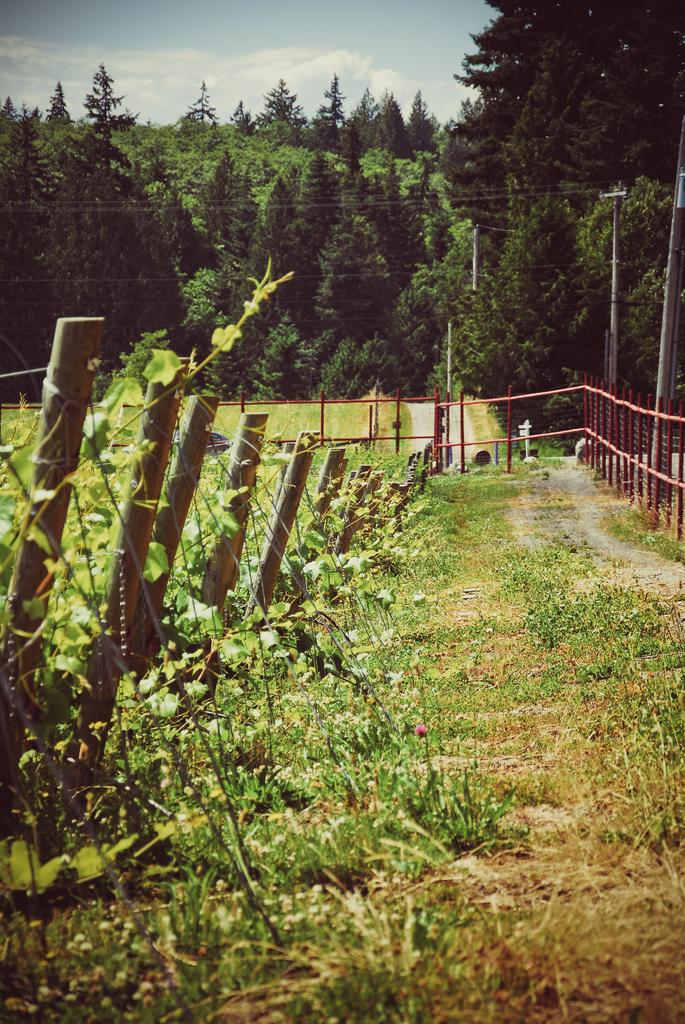What structures are located in the center of the image? There is a fence and some poles in the center of the image. What type of vegetation is at the bottom of the image? There is grass and some plants at the bottom of the image. What can be seen in the background of the image? There are trees in the background of the image. What is visible at the top of the image? The sky is visible at the top of the image. How many men are holding meat in the image? There are no men or meat present in the image. What type of apple is visible in the image? There is no apple present in the image. 